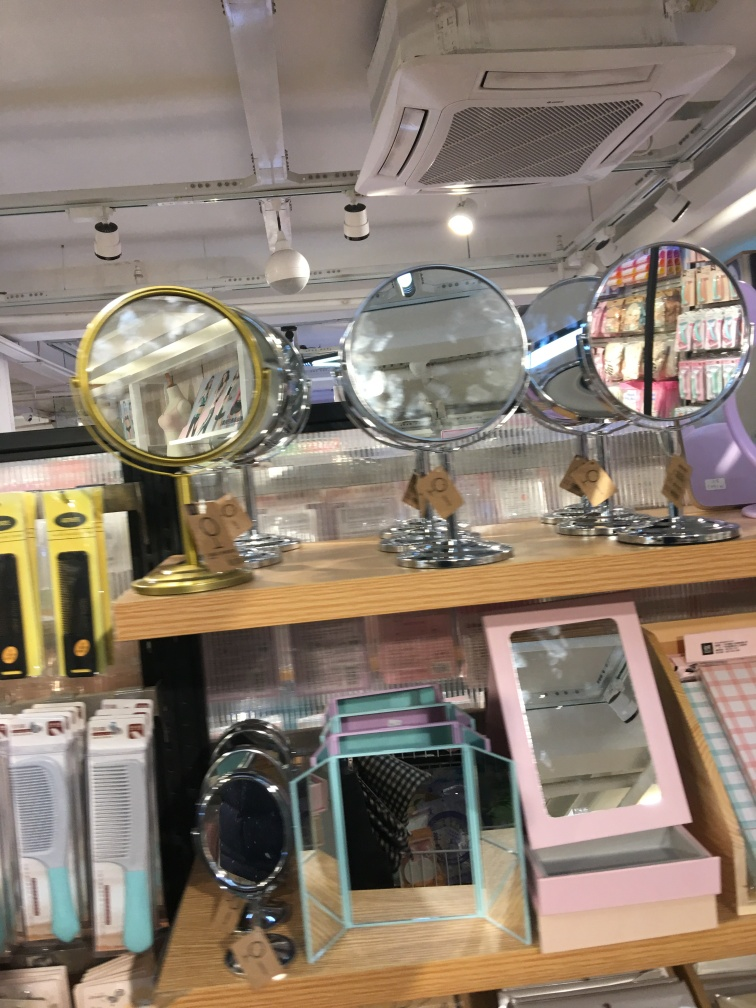Are there any quality issues with this image? Indeed, there are several quality issues with the image provided. It is slightly tilted, which affects the symmetry and composition of the photo. The focus is not sharp, causing some objects to appear blurry. Furthermore, the lighting in the image is uneven, leading to reflections on the mirrors that may distract from the main subjects of the photo. A steadier hand, better focus, and more consistent lighting could significantly improve the quality of this image. 